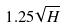<formula> <loc_0><loc_0><loc_500><loc_500>1 . 2 5 \sqrt { H }</formula> 